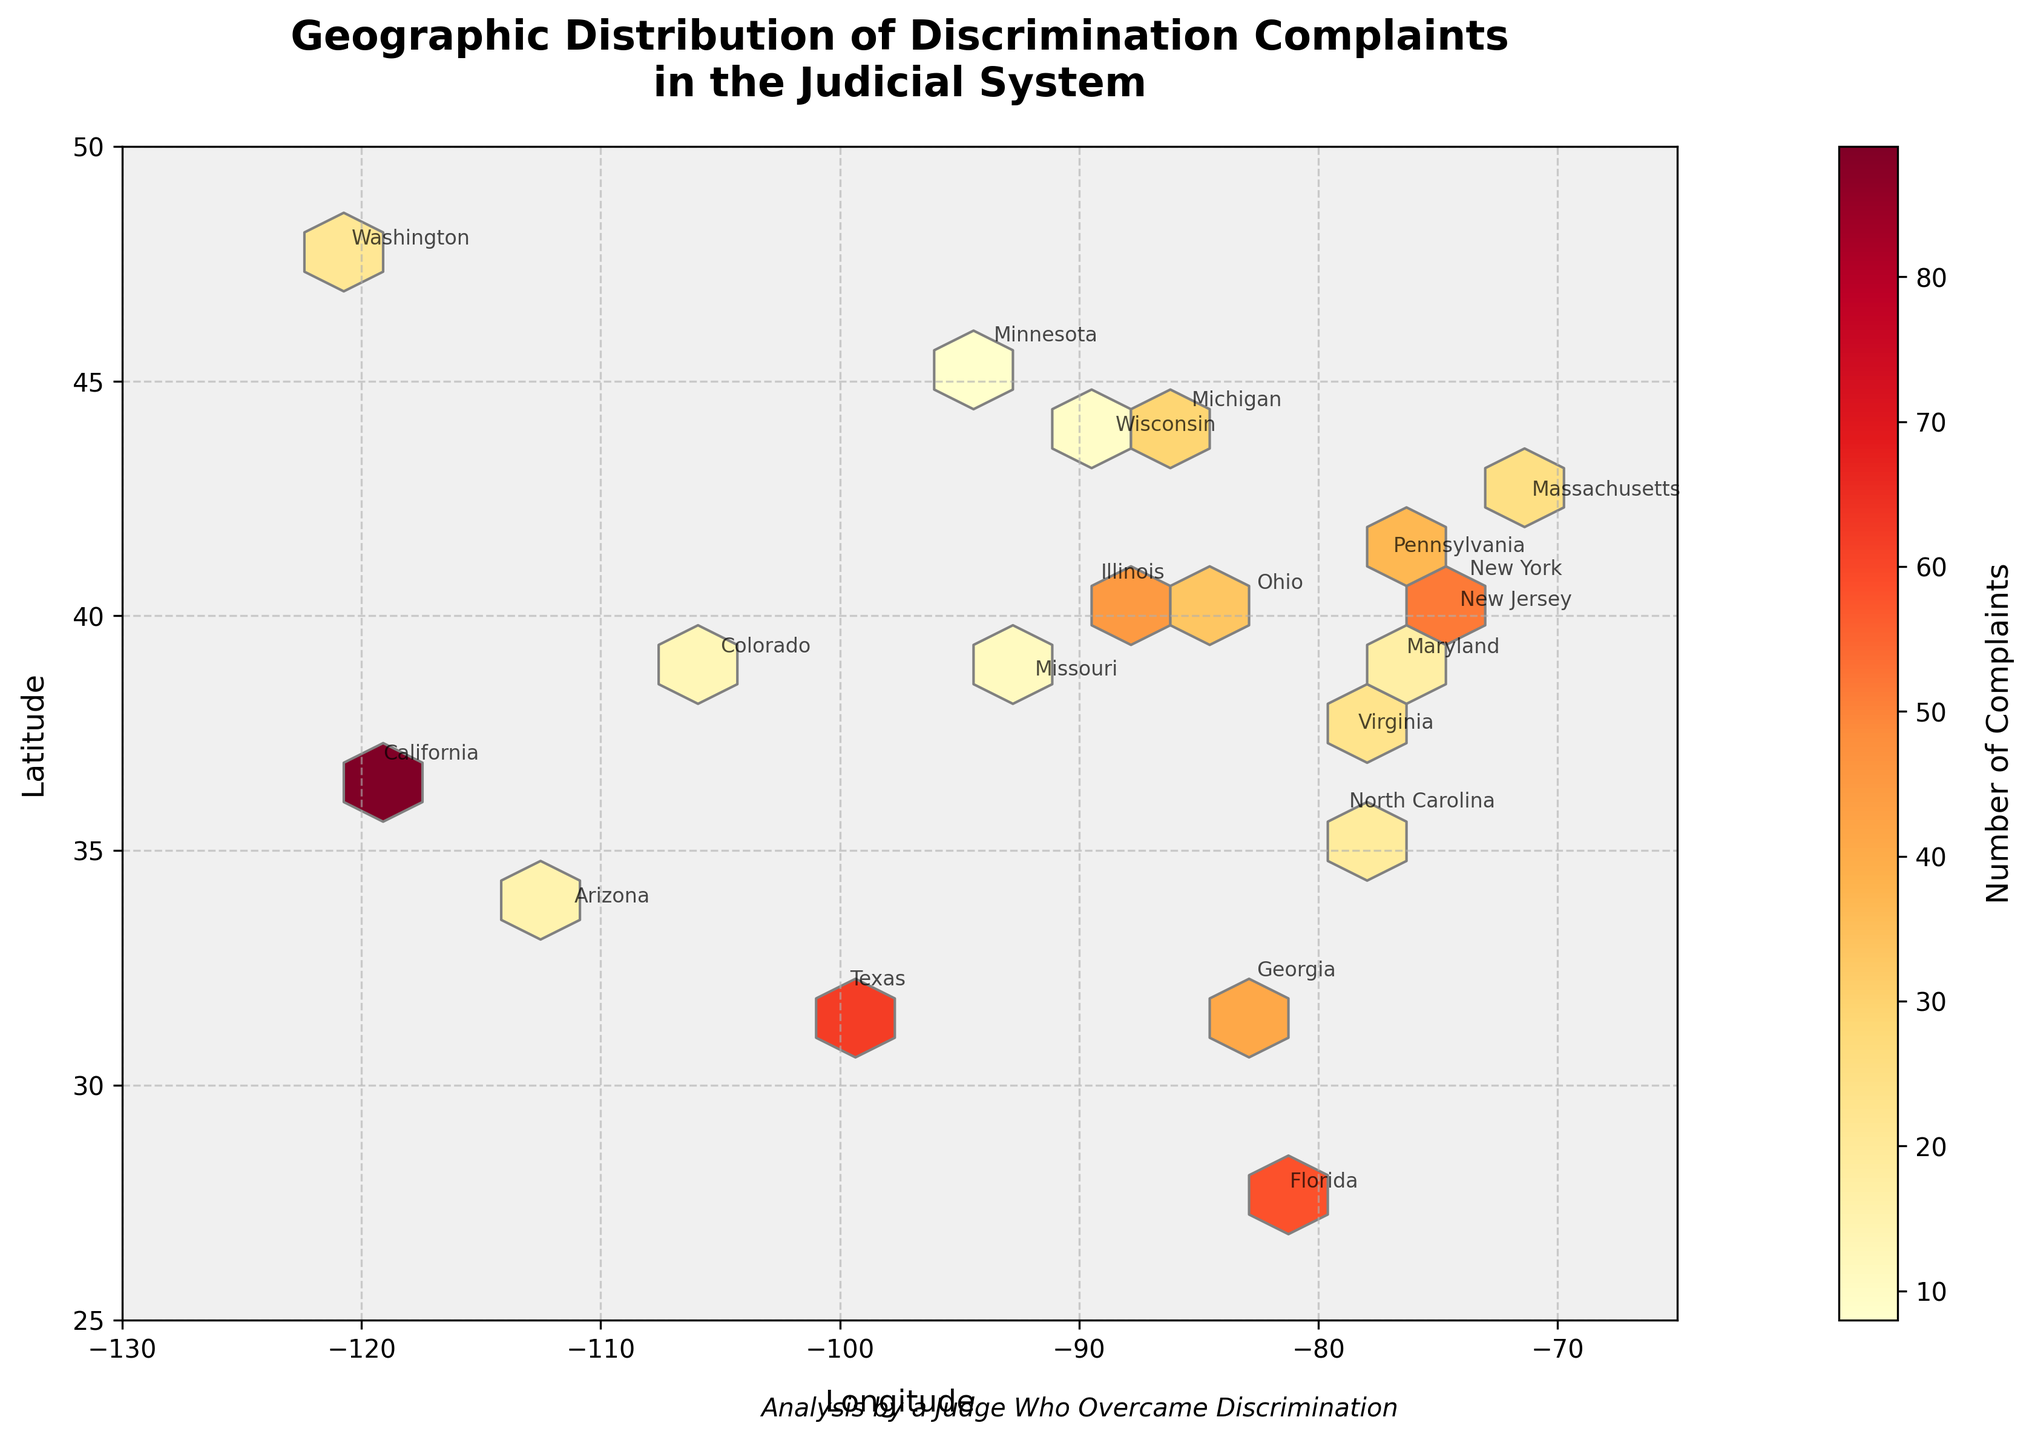What does the title of the plot indicate? The title of the plot is "Geographic Distribution of Discrimination Complaints in the Judicial System," which indicates that the plot shows the spread of discrimination complaints geographically throughout the judicial system in different states.
Answer: Geographic Distribution of Discrimination Complaints in the Judicial System What geographic location shows the highest density of complaints? The plot uses a color gradient where darker colors represent higher densities of complaints. Observing the figure, California has the highest density cluster which is evident from the darkest color.
Answer: California Which state has a higher number of complaints, Texas or Florida? By looking at the annotated state names and comparing the number of complaints, Texas has 62 complaints while Florida has 58. Therefore, Texas has a higher number of complaints.
Answer: Texas How are the colors used in the plot, and what do they represent? The hexbin plot uses a colormap (YlOrRd) where lighter colors represent lower number of complaints, and darker colors represent higher number of complaints. The exact values can be inferred from the colorbar.
Answer: Colors represent the number of complaints Which state in the northeastern part of the United States has the highest number of complaints? In the northeastern part of the U.S., New York stands out with the highest number of complaints, marked by an annotation near the corresponding hexbin.
Answer: New York What is the range of longitude displayed on the x-axis? The x-axis ranges from -130 to -65, as seen from the tick marks on the plot's horizontal axis.
Answer: -130 to -65 Is there a significant cluster of complaints in the Midwest region, and if so, in which state? The Midwest region shows a noticeable cluster of complaints around Illinois, as indicated by the density and the color gradient in that area.
Answer: Illinois Which state has the least number of complaints? Based on the annotated data points, Minnesota has the least number of complaints with 8.
Answer: Minnesota How is the colorbar labeled, and what information does it provide? The colorbar is labeled "Number of Complaints." It provides a gradient scale that helps interpret the density of complaints in each hexbin by matching the colors to the number of complaints.
Answer: Number of Complaints 